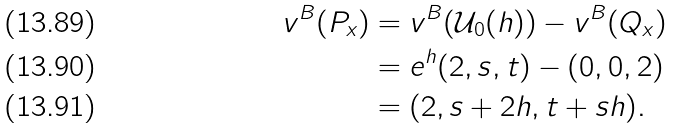Convert formula to latex. <formula><loc_0><loc_0><loc_500><loc_500>v ^ { B } ( P _ { x } ) & = v ^ { B } ( \mathcal { U } _ { 0 } ( h ) ) - v ^ { B } ( Q _ { x } ) \\ & = e ^ { h } ( 2 , s , t ) - ( 0 , 0 , 2 ) \\ & = ( 2 , s + 2 h , t + s h ) .</formula> 